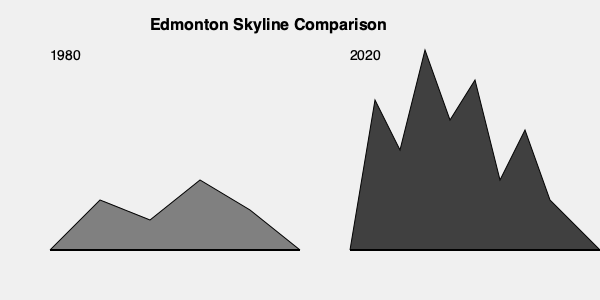Based on the silhouette comparison of Edmonton's skyline from 1980 to 2020, what is the most significant change observed in the city's architectural landscape? To answer this question, let's analyze the skyline silhouettes step-by-step:

1. 1980 Skyline:
   - The buildings are relatively uniform in height.
   - The tallest structure is approximately 70 units high (180 on the y-axis).
   - There are about 5-6 notable structures visible.

2. 2020 Skyline:
   - The buildings vary greatly in height.
   - The tallest structure is approximately 200 units high (50 on the y-axis).
   - There are about 8-9 notable structures visible.

3. Comparing the two skylines:
   - The 2020 skyline is significantly taller overall.
   - There is more variation in building heights in 2020.
   - The number of tall structures has increased.

4. Calculating the change in maximum height:
   Let $h_{1980}$ be the height of the tallest building in 1980 and $h_{2020}$ for 2020.
   
   Increase in height = $h_{2020} - h_{1980}$ = 200 - 70 = 130 units
   
   Percentage increase = $\frac{h_{2020} - h_{1980}}{h_{1980}} \times 100\%$ = $\frac{130}{70} \times 100\%$ ≈ 185.7%

5. Conclusion:
   The most significant change is the dramatic increase in building heights, with the tallest structures nearly tripling in size. This vertical growth indicates a shift towards high-rise development and a more dense urban core.
Answer: Dramatic increase in building heights and density 